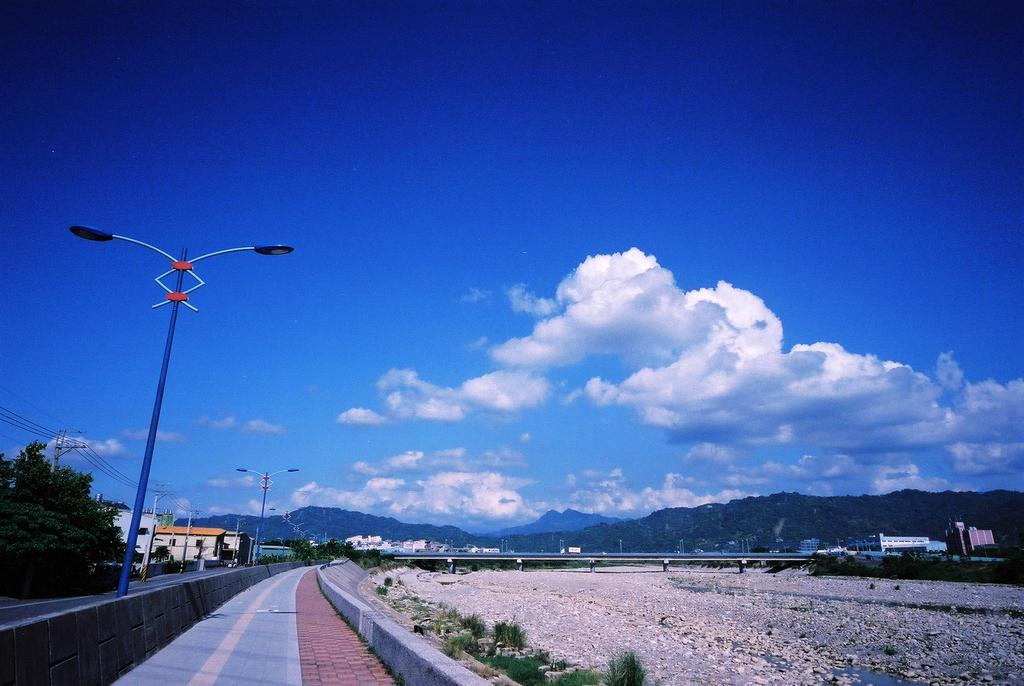What type of vegetation can be seen in the image? There is grass in the image. What structures are present in the image? There are poles, a bridge, and buildings in the image. What natural features can be seen in the image? There are trees and a mountain in the image. What is visible in the background of the image? The sky is visible in the background of the image, and there are clouds in the sky. How many chairs are placed on the bridge in the image? There are no chairs present on the bridge in the image. What type of door can be seen in the image? There is no door present in the image. 